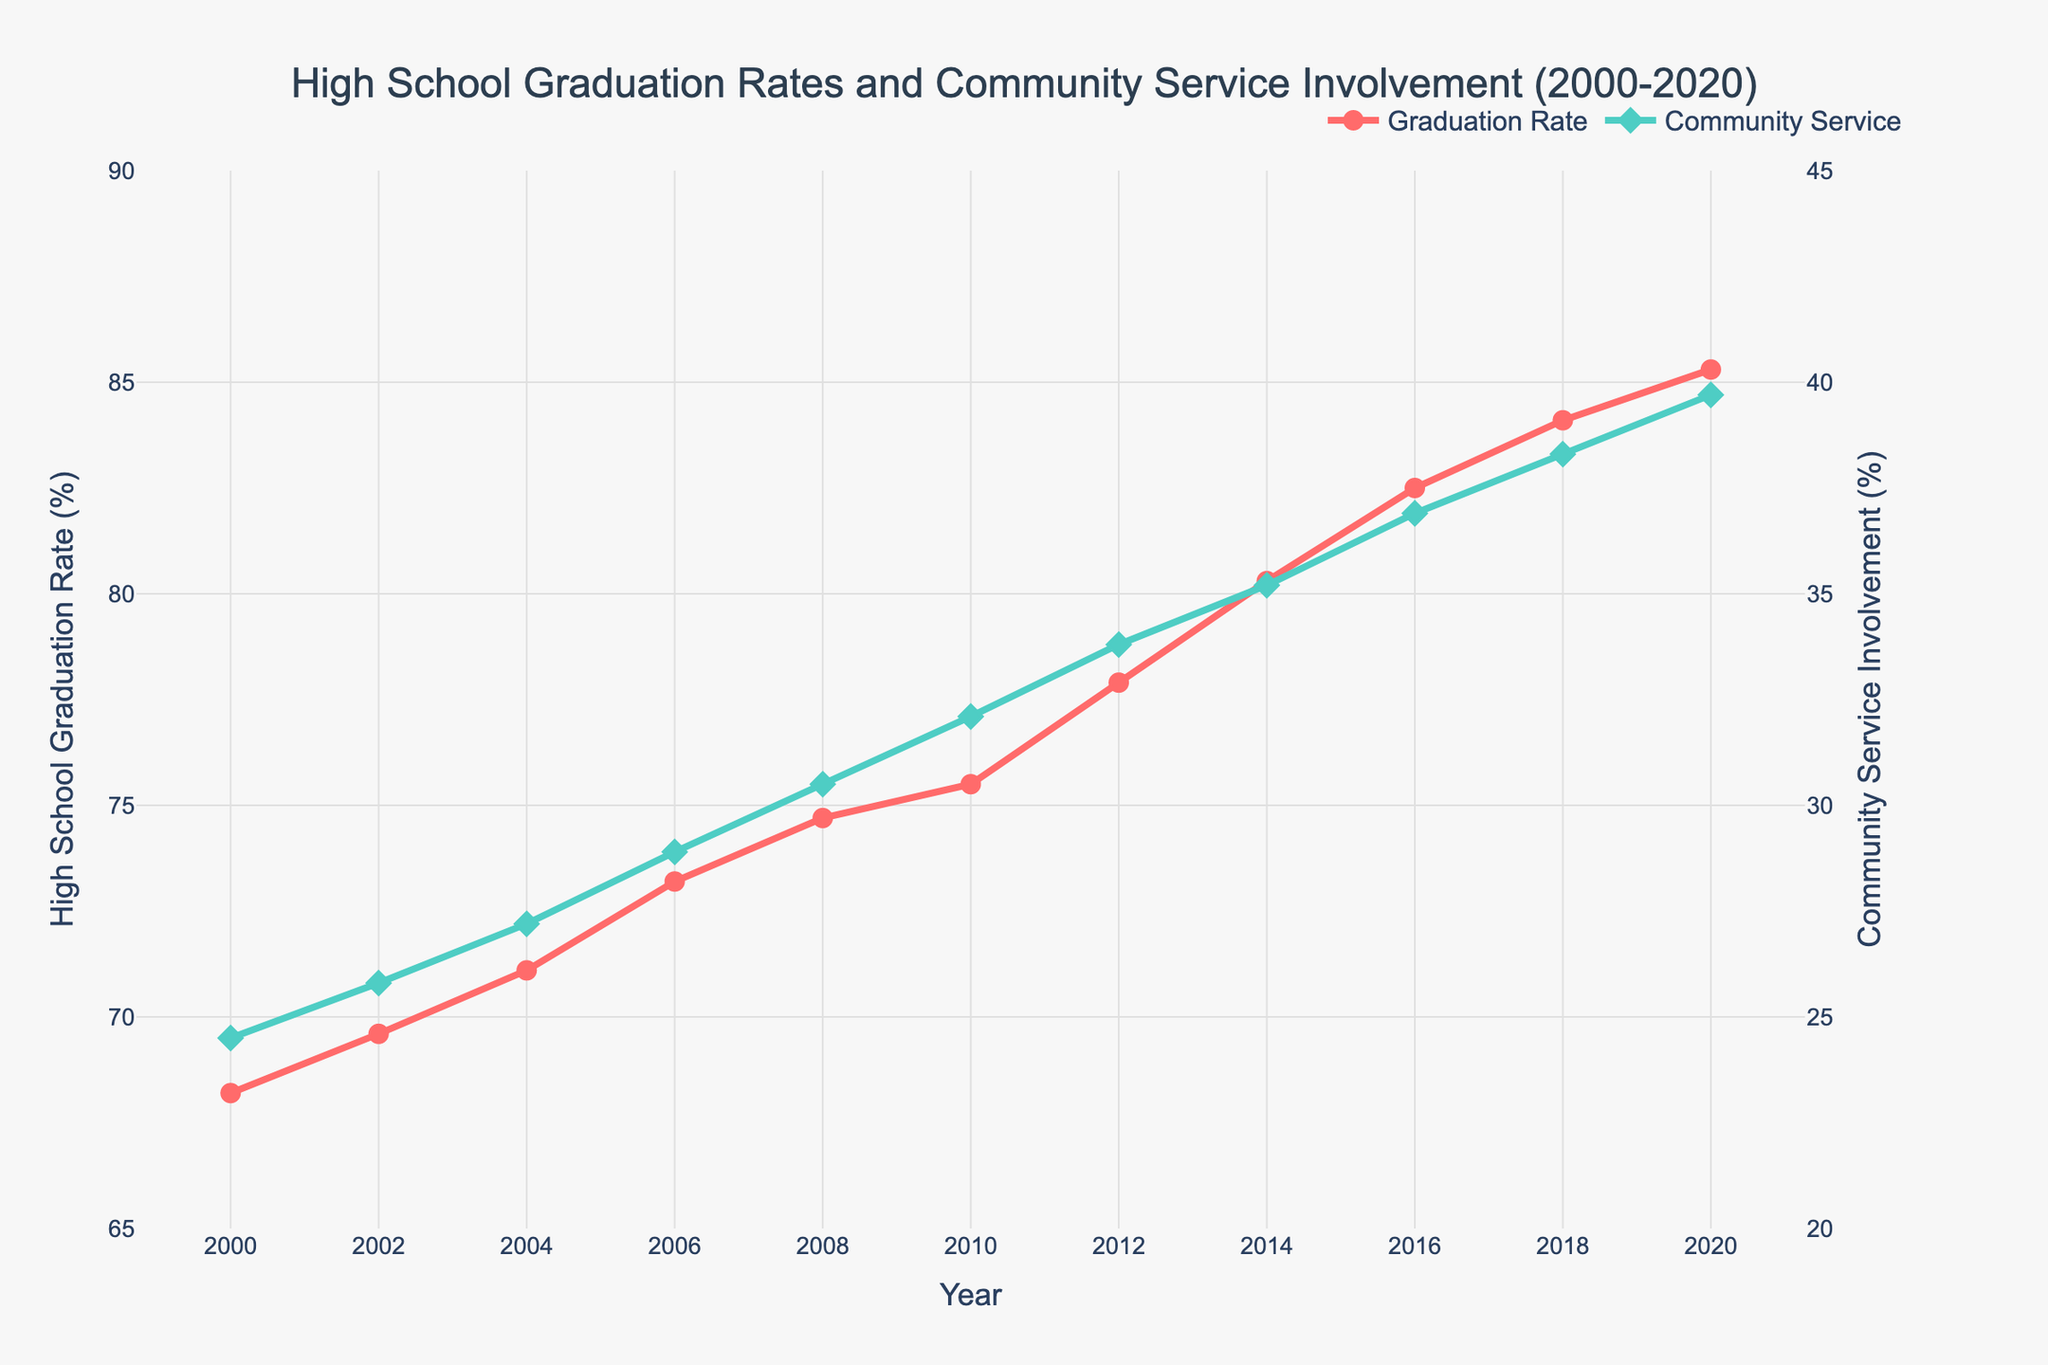What is the high school graduation rate in 2010? The graduation rate for any given year can be read directly from the y-axis corresponding to the "Graduation Rate" line (red line) in the figure. For the year 2010, locate the point on the red line.
Answer: 75.5% How much did the community service involvement rate increase from 2000 to 2020? Find the community service involvement rates for the years 2000 and 2020 and calculate the difference: 39.7% (2020) - 24.5% (2000).
Answer: 15.2% In which year did the high school graduation rate first exceed 80%? Locate the point on the red line that first surpasses the 80% mark on the y-axis. This occurs at the year 2014.
Answer: 2014 What was the community service involvement rate in 2008? The community service involvement rate for any given year can be read directly from the y-axis corresponding to the "Community Service" line (green line) in the figure. For the year 2008, find the point on the green line.
Answer: 30.5% Did the high school graduation rate ever decline between 2000 and 2020? Examine the trend of the red line (graduation rate) throughout the entire period. There is no point where the red line declines; it consistently increases.
Answer: No In which year was the gap between high school graduation rate and community service involvement the smallest? Calculate the differences between the graduation and community service rates for each year and identify the smallest difference. This occurs in 2020, with a gap of 85.3% - 39.7% = 45.6%.
Answer: 2020 How many years did it take for the high school graduation rate to increase from 70% to 80%? Identify the years when the graduation rate was 70% and 80%, respectively. For 70%, it’s around 2002, and for 80%, it’s 2014. Thus, 2014-2002 = 12 years.
Answer: 12 years Which rate grew faster between 2000 to 2020: high school graduation rate or community service involvement? Calculate the percentage increase for both rates. Graduation rate: (85.3-68.2)/68.2 * 100 ≈ 25.1%. Community service: (39.7-24.5)/24.5 * 100 ≈ 62%. Community service grew faster.
Answer: Community service involvement In 2016, was the increase in high school graduation rate or community service involvement larger compared to the previous year? Compare the increments from 2014 to 2016 for both metrics. Graduation rate increased from 80.3% to 82.5% (2.2%), while community service increased from 35.2% to 36.9% (1.7%). The graduation rate had a larger increase.
Answer: High school graduation rate By how much did the community service involvement rate change between 2014 and 2016? Subtract the community service involvement rate in 2014 from the rate in 2016: 36.9% - 35.2%.
Answer: 1.7% 